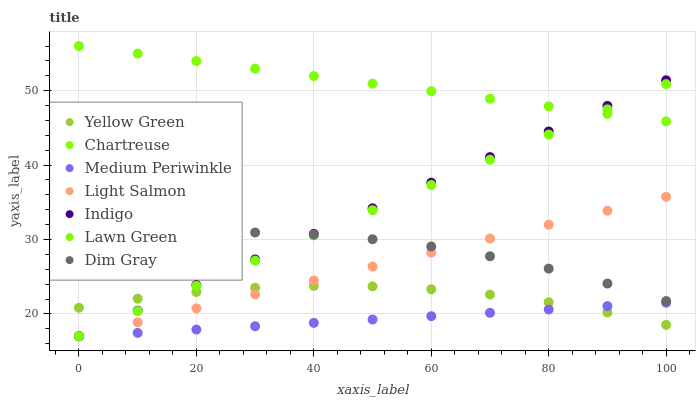Does Medium Periwinkle have the minimum area under the curve?
Answer yes or no. Yes. Does Chartreuse have the maximum area under the curve?
Answer yes or no. Yes. Does Light Salmon have the minimum area under the curve?
Answer yes or no. No. Does Light Salmon have the maximum area under the curve?
Answer yes or no. No. Is Medium Periwinkle the smoothest?
Answer yes or no. Yes. Is Dim Gray the roughest?
Answer yes or no. Yes. Is Light Salmon the smoothest?
Answer yes or no. No. Is Light Salmon the roughest?
Answer yes or no. No. Does Lawn Green have the lowest value?
Answer yes or no. Yes. Does Dim Gray have the lowest value?
Answer yes or no. No. Does Chartreuse have the highest value?
Answer yes or no. Yes. Does Light Salmon have the highest value?
Answer yes or no. No. Is Dim Gray less than Chartreuse?
Answer yes or no. Yes. Is Chartreuse greater than Dim Gray?
Answer yes or no. Yes. Does Medium Periwinkle intersect Light Salmon?
Answer yes or no. Yes. Is Medium Periwinkle less than Light Salmon?
Answer yes or no. No. Is Medium Periwinkle greater than Light Salmon?
Answer yes or no. No. Does Dim Gray intersect Chartreuse?
Answer yes or no. No. 